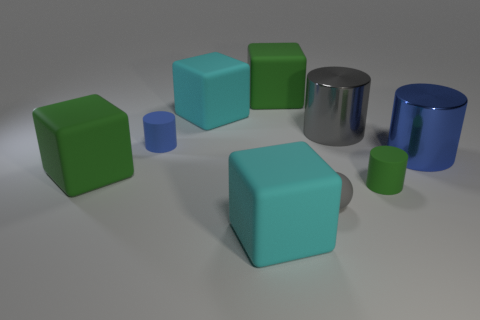What number of cyan objects are either rubber cubes or rubber balls? 2 